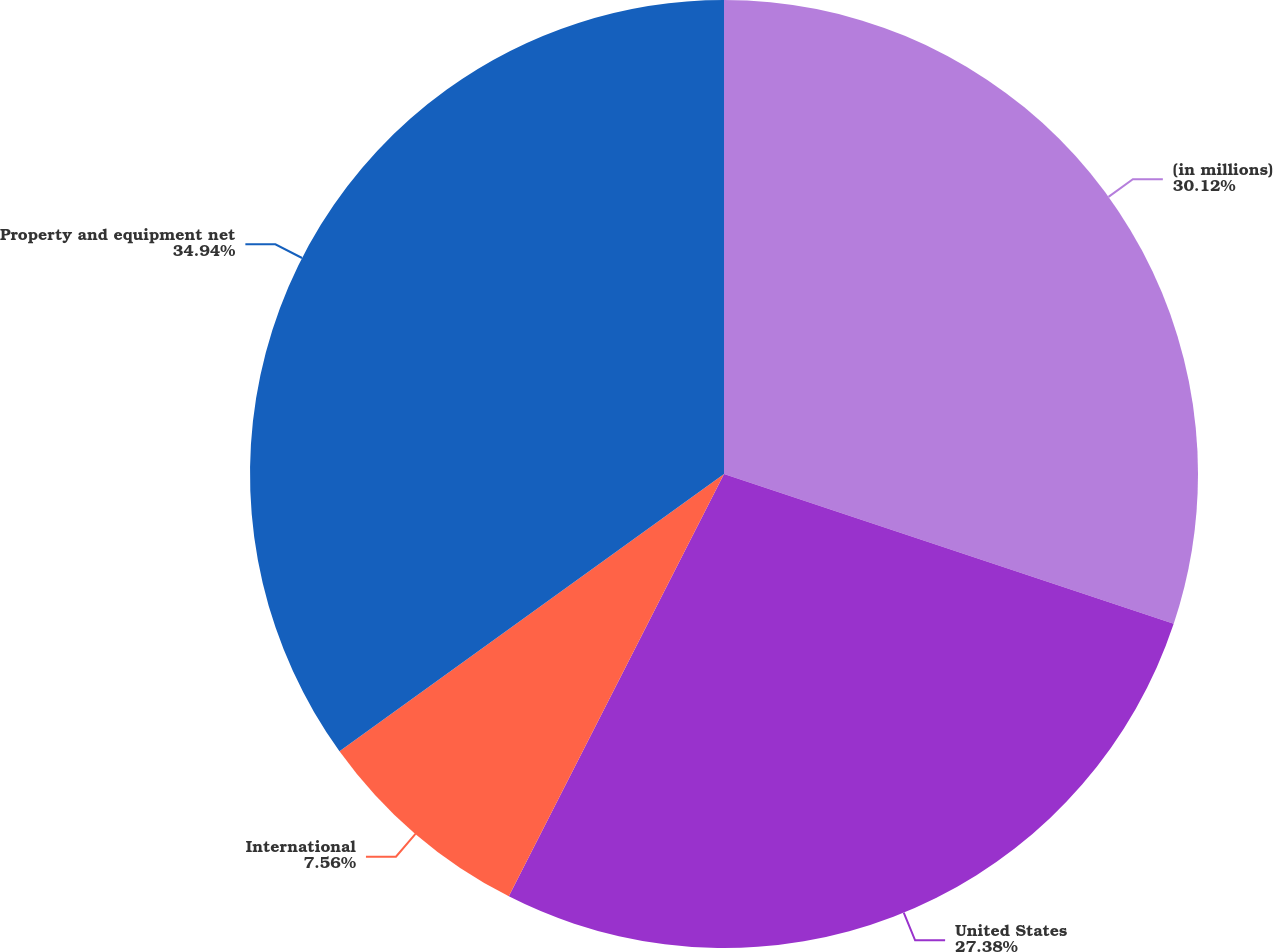<chart> <loc_0><loc_0><loc_500><loc_500><pie_chart><fcel>(in millions)<fcel>United States<fcel>International<fcel>Property and equipment net<nl><fcel>30.12%<fcel>27.38%<fcel>7.56%<fcel>34.94%<nl></chart> 